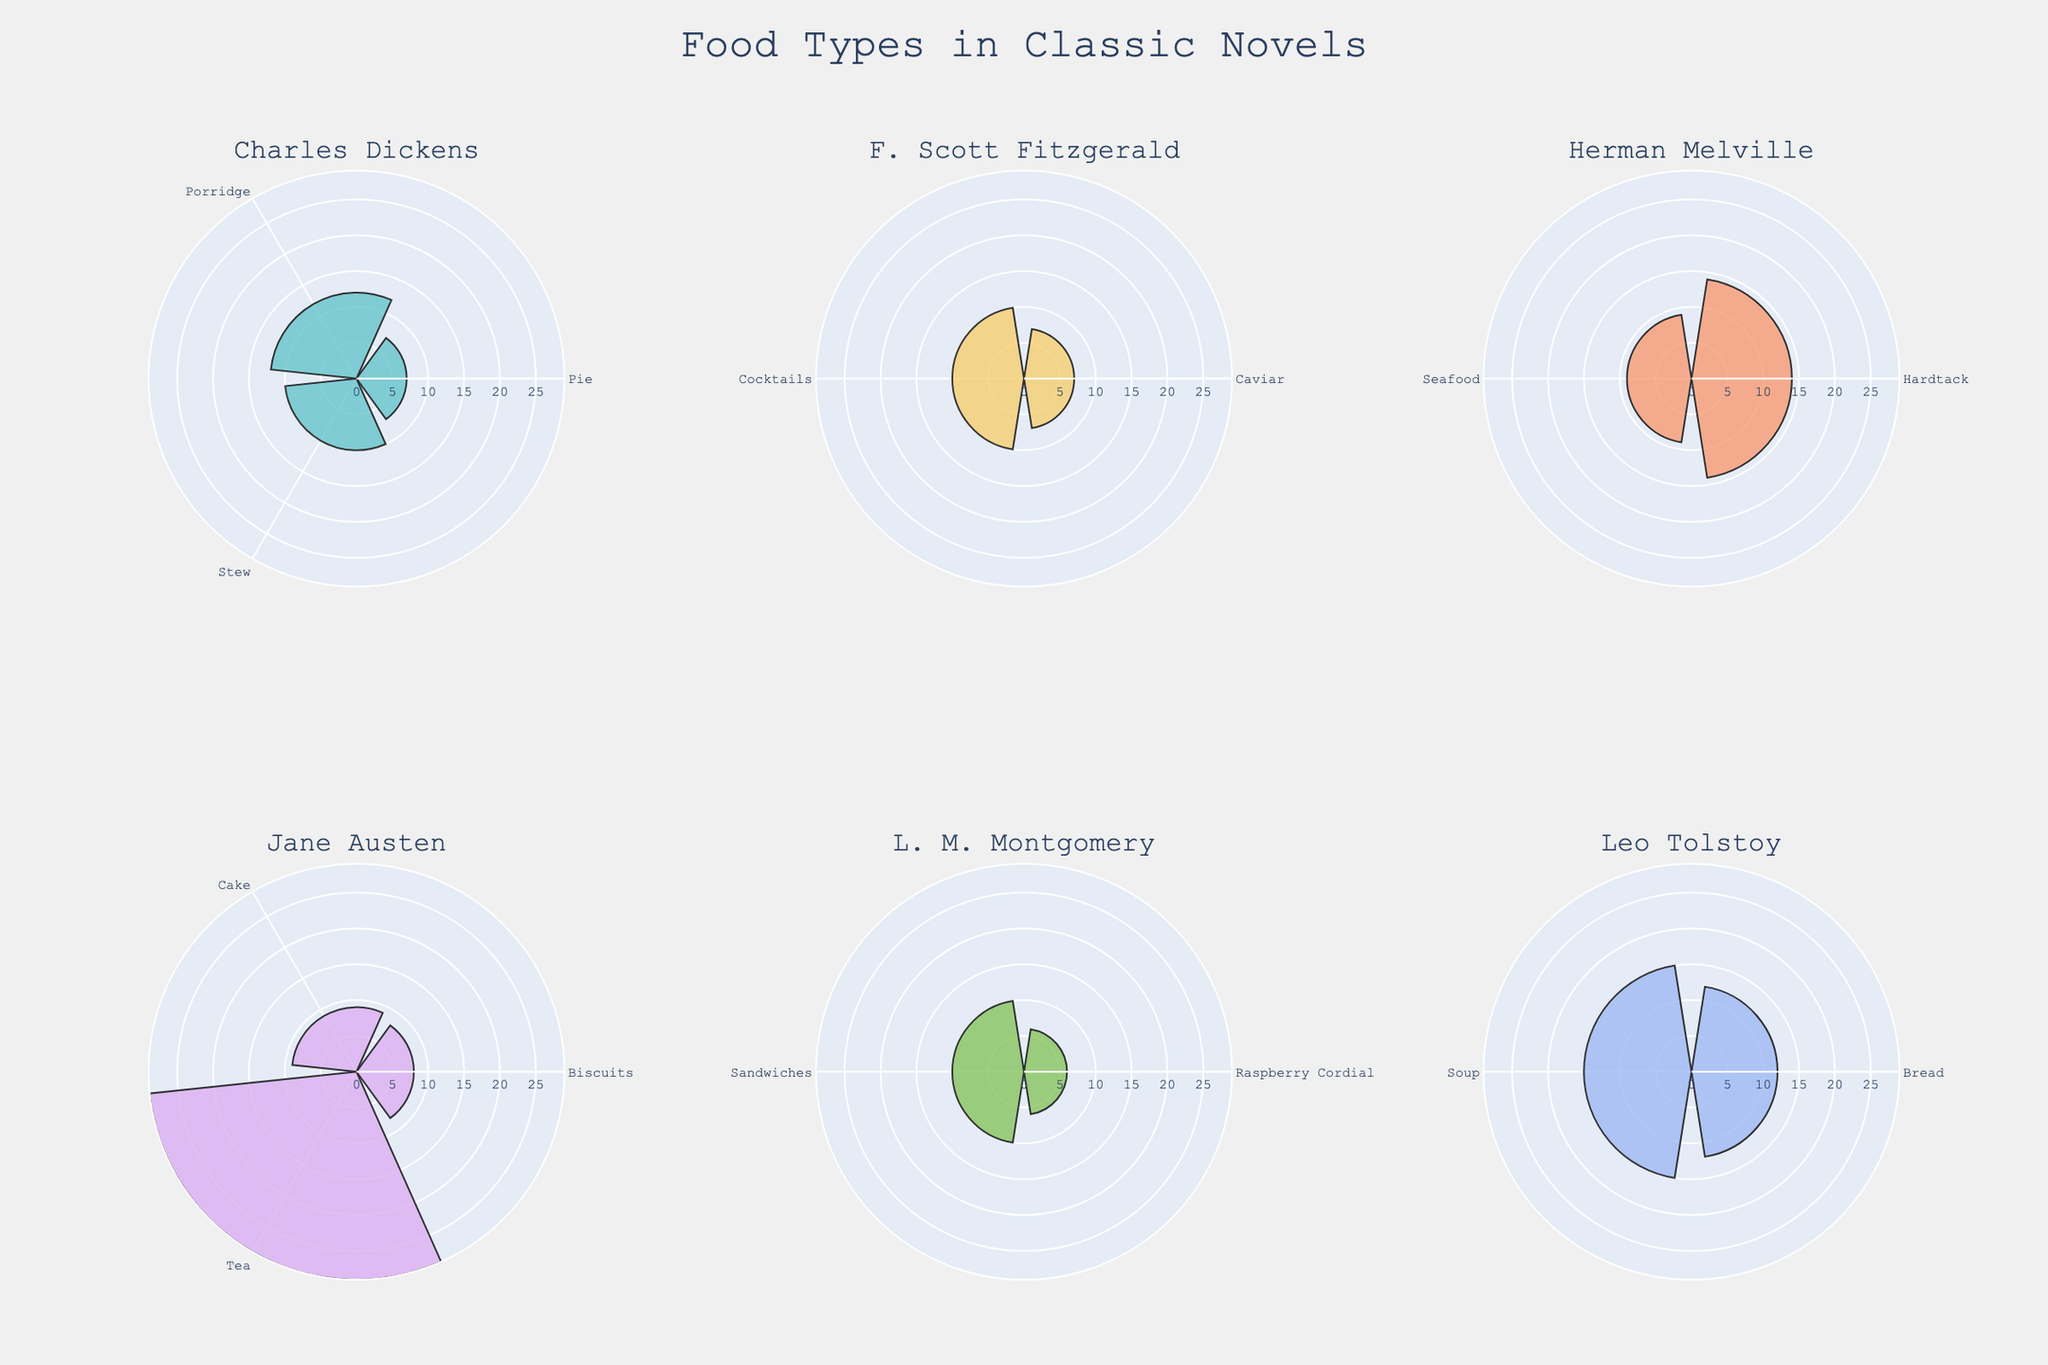What is the food type with the highest count featured in "Pride and Prejudice"? By examining the rose chart section for Jane Austen, check the segments labeled with food types mentioned in "Pride and Prejudice". The segment with the largest arc or length is "Tea".
Answer: Tea Which author features the most food types in their novels? Count the segments in each author's dedicated rose plot. The author with the most unique segments is Charles Dickens, as he accounts for Stew, Porridge, and Pie across his novels "Oliver Twist" and "Great Expectations".
Answer: Charles Dickens What is the combined count of Tea featured in all novels by Jane Austen? Add the counts of Tea from "Pride and Prejudice" and "Emma" in Jane Austen's segments: 15 (Pride and Prejudice) + 14 (Emma) = 29.
Answer: 29 Which food type is mentioned more frequently in "War and Peace": Bread or Soup? Compare the radial distance of the segments for Bread and Soup under Leo Tolstoy's section. The radial length for Soup (15) is greater than for Bread (12).
Answer: Soup How does the count of Seafood in "Moby-Dick" compare to Raspberry Cordial in "Anne of Green Gables"? Check the radial lengths for Seafood in Herman Melville's section and Raspberry Cordial in L. M. Montgomery's section. Seafood has a length of 9 while Raspberry Cordial has a length of 6. Thus, Seafood is mentioned more often.
Answer: Seafood What is the average count of food types in "Oliver Twist"? Sum the counts of all food types in "Oliver Twist" (Stew: 10, Porridge: 12) and then divide by the number of types. (10 + 12) / 2 = 22 / 2 = 11.
Answer: 11 Which novel features Hardtack, and what is its count? Look at the segments labeled "Hardtack" and identify its location. It appears under Herman Melville's section, associated with "Moby-Dick" at a count of 14.
Answer: Moby-Dick, 14 How many food types are shown in the chart for "Anne of Green Gables" by L. M. Montgomery? Count the distinct segments labeled in L. M. Montgomery's plot area, which are Raspberry Cordial and Sandwiches, resulting in two food types.
Answer: 2 